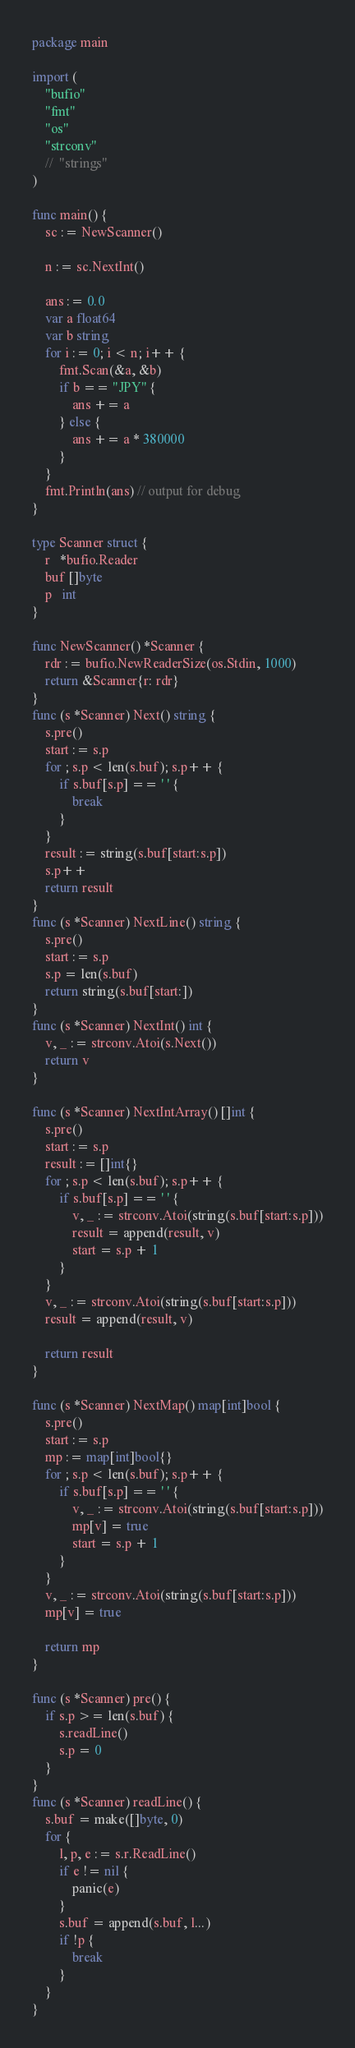<code> <loc_0><loc_0><loc_500><loc_500><_Go_>package main

import (
	"bufio"
	"fmt"
	"os"
	"strconv"
	//	"strings"
)

func main() {
	sc := NewScanner()

	n := sc.NextInt()

	ans := 0.0
	var a float64
	var b string
	for i := 0; i < n; i++ {
		fmt.Scan(&a, &b)
		if b == "JPY" {
			ans += a
		} else {
			ans += a * 380000
		}
	}
	fmt.Println(ans) // output for debug
}

type Scanner struct {
	r   *bufio.Reader
	buf []byte
	p   int
}

func NewScanner() *Scanner {
	rdr := bufio.NewReaderSize(os.Stdin, 1000)
	return &Scanner{r: rdr}
}
func (s *Scanner) Next() string {
	s.pre()
	start := s.p
	for ; s.p < len(s.buf); s.p++ {
		if s.buf[s.p] == ' ' {
			break
		}
	}
	result := string(s.buf[start:s.p])
	s.p++
	return result
}
func (s *Scanner) NextLine() string {
	s.pre()
	start := s.p
	s.p = len(s.buf)
	return string(s.buf[start:])
}
func (s *Scanner) NextInt() int {
	v, _ := strconv.Atoi(s.Next())
	return v
}

func (s *Scanner) NextIntArray() []int {
	s.pre()
	start := s.p
	result := []int{}
	for ; s.p < len(s.buf); s.p++ {
		if s.buf[s.p] == ' ' {
			v, _ := strconv.Atoi(string(s.buf[start:s.p]))
			result = append(result, v)
			start = s.p + 1
		}
	}
	v, _ := strconv.Atoi(string(s.buf[start:s.p]))
	result = append(result, v)

	return result
}

func (s *Scanner) NextMap() map[int]bool {
	s.pre()
	start := s.p
	mp := map[int]bool{}
	for ; s.p < len(s.buf); s.p++ {
		if s.buf[s.p] == ' ' {
			v, _ := strconv.Atoi(string(s.buf[start:s.p]))
			mp[v] = true
			start = s.p + 1
		}
	}
	v, _ := strconv.Atoi(string(s.buf[start:s.p]))
	mp[v] = true

	return mp
}

func (s *Scanner) pre() {
	if s.p >= len(s.buf) {
		s.readLine()
		s.p = 0
	}
}
func (s *Scanner) readLine() {
	s.buf = make([]byte, 0)
	for {
		l, p, e := s.r.ReadLine()
		if e != nil {
			panic(e)
		}
		s.buf = append(s.buf, l...)
		if !p {
			break
		}
	}
}
</code> 